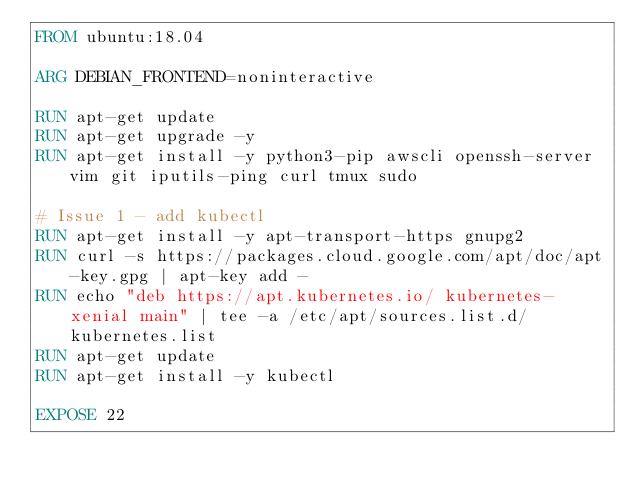<code> <loc_0><loc_0><loc_500><loc_500><_Dockerfile_>FROM ubuntu:18.04

ARG DEBIAN_FRONTEND=noninteractive

RUN apt-get update
RUN apt-get upgrade -y
RUN apt-get install -y python3-pip awscli openssh-server vim git iputils-ping curl tmux sudo

# Issue 1 - add kubectl
RUN apt-get install -y apt-transport-https gnupg2
RUN curl -s https://packages.cloud.google.com/apt/doc/apt-key.gpg | apt-key add -
RUN echo "deb https://apt.kubernetes.io/ kubernetes-xenial main" | tee -a /etc/apt/sources.list.d/kubernetes.list
RUN apt-get update
RUN apt-get install -y kubectl

EXPOSE 22
</code> 